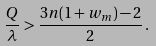Convert formula to latex. <formula><loc_0><loc_0><loc_500><loc_500>\frac { Q } { \lambda } > \frac { 3 n ( 1 + w _ { m } ) - 2 } { 2 } \, .</formula> 